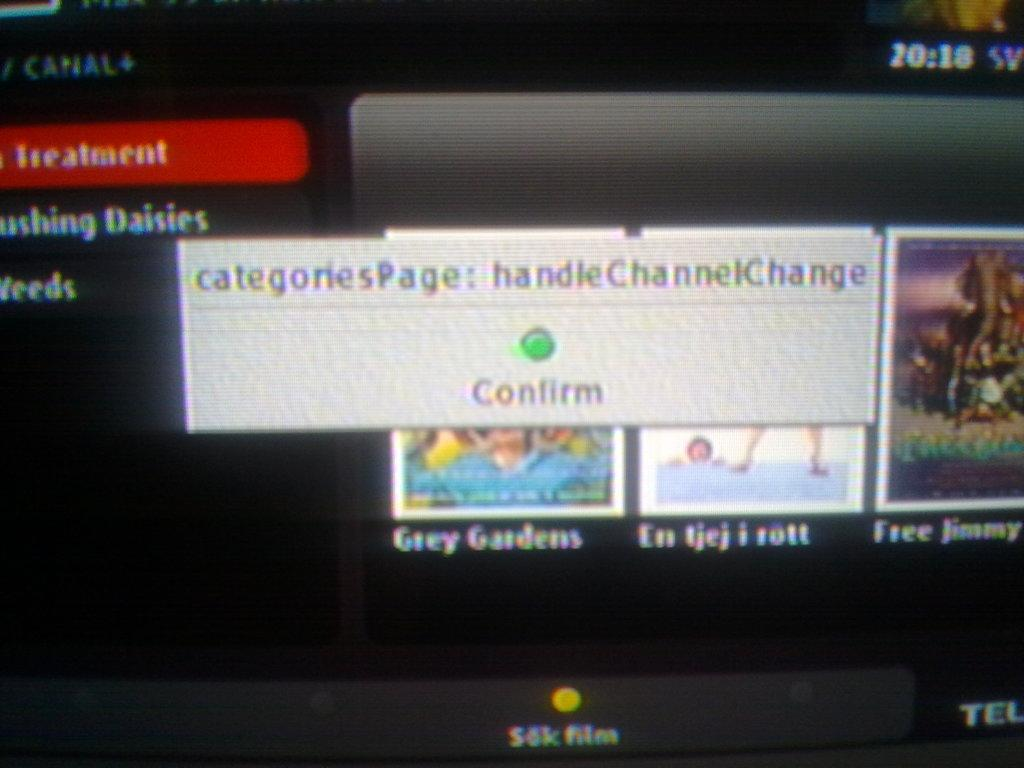<image>
Summarize the visual content of the image. the word confirm that is written on a screen 